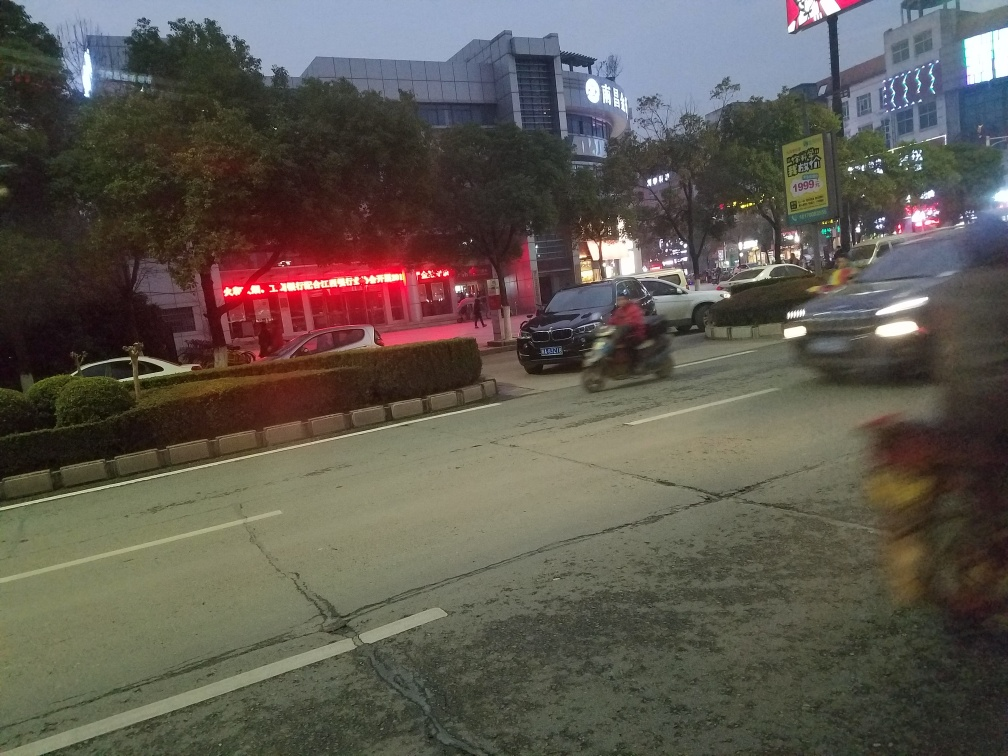Can you infer the type of area depicted in the image, and what suggests this? The image seems to depict an urban commercial area, as suggested by the lit signage, storefronts, and the presence of multiple vehicles on the road. The density of advertising and the broad roadway are typical characteristics of a bustling city area with active commerce. What does the presence of neon signs and advertisements indicate about the local culture? The neon signs and advertisements suggest that the local culture is vibrant and commercialized. Neon signs are often associated with night-time economies, suggesting that the area is likely to be lively during the evening, with shops and businesses that cater to people seeking entertainment, dining, and shopping experiences after dark. 